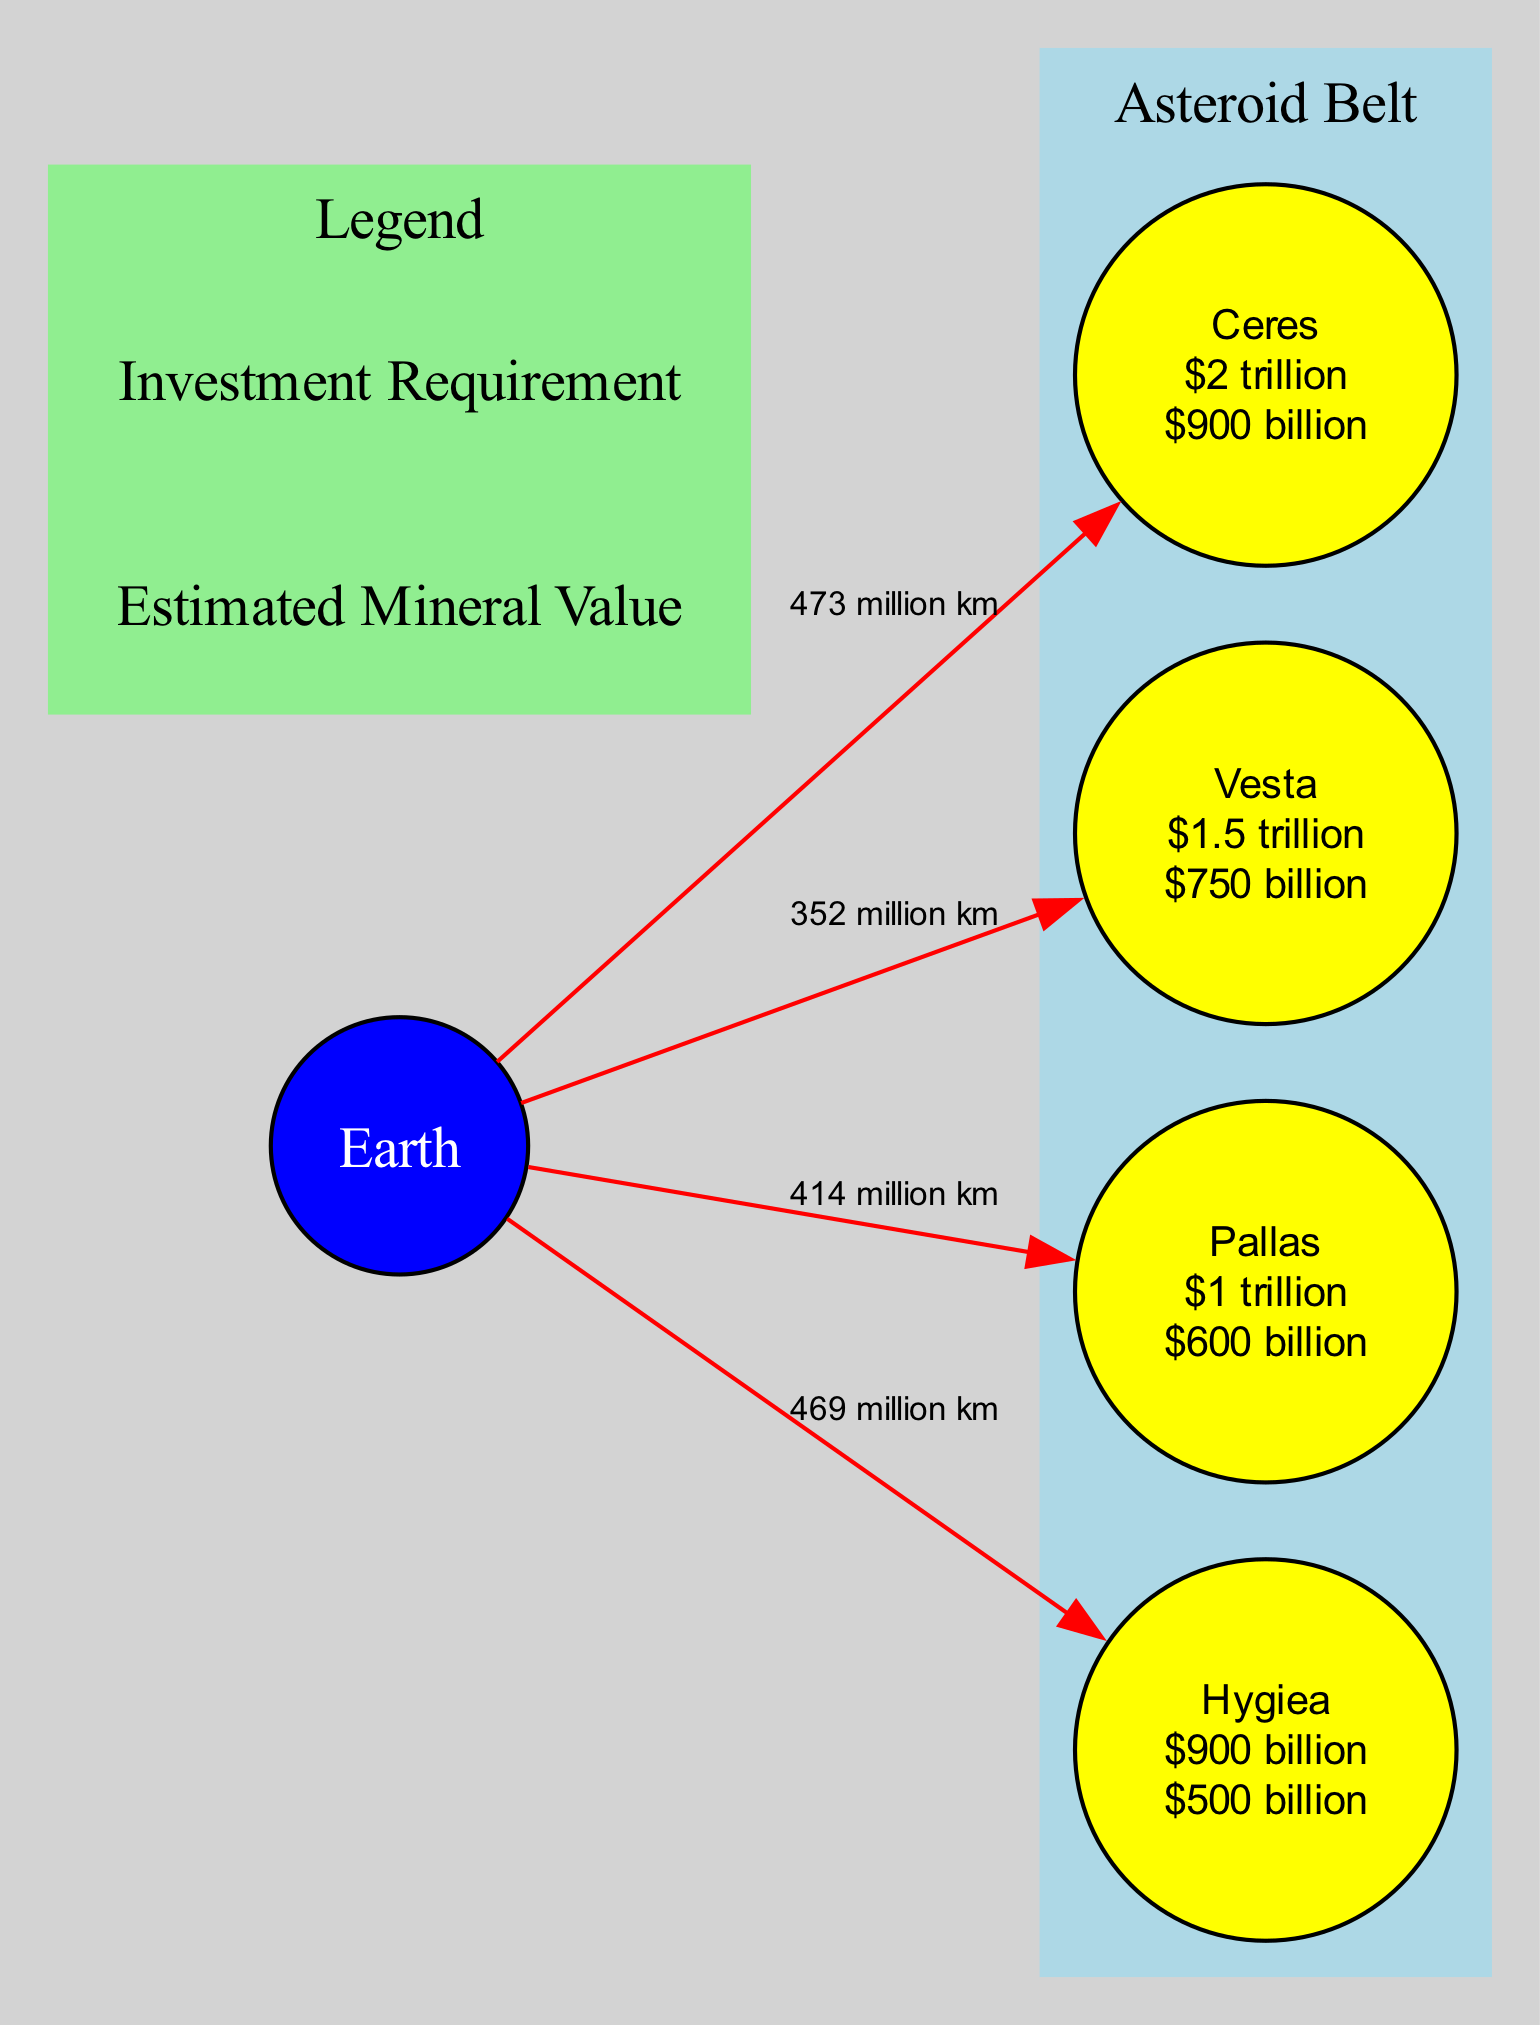What is the estimated mineral value of Ceres? The diagram labels Ceres with an estimated mineral value of $2 trillion. By directly referring to the node representing Ceres, we can see its specific value displayed clearly.
Answer: $2 trillion What is the investment requirement for Vesta? The diagram shows that Vesta has an investment requirement of $750 billion. This information is obtained by looking at Vesta's description in the asteroid node.
Answer: $750 billion How far is Hygiea from Earth? The diagram indicates that the distance from Earth to Hygiea is 469 million kilometers, which is clearly labeled along the route line connecting these two nodes.
Answer: 469 million km Which asteroid has the highest estimated mineral value? By comparing the estimated mineral values listed in the nodes for Ceres, Vesta, Pallas, and Hygiea, it is evident that Ceres has the highest estimated mineral value of $2 trillion.
Answer: Ceres What is the total investment requirement for Pallas and Hygiea combined? The diagram shows Pallas has an investment requirement of $600 billion and Hygiea has $500 billion. Adding these amounts, we get $600 billion + $500 billion = $1.1 trillion.
Answer: $1.1 trillion How many asteroids are listed in the diagram? The diagram has a total of four asteroids labeled: Ceres, Vesta, Pallas, and Hygiea. Counting these nodes gives us the total number of asteroids present.
Answer: 4 What is the difference in estimated mineral value between Vesta and Hygiea? Vesta has an estimated mineral value of $1.5 trillion, while Hygiea has $900 billion. The difference is calculated by subtracting Hygiea's value from Vesta's: $1.5 trillion - $900 billion = $600 billion.
Answer: $600 billion Which route has the shortest distance to Earth? The diagram shows that the distance from Earth to Vesta is 352 million kilometers, which is shorter than the distances to the other asteroids. Thus, Vesta has the shortest distance to Earth.
Answer: Vesta 